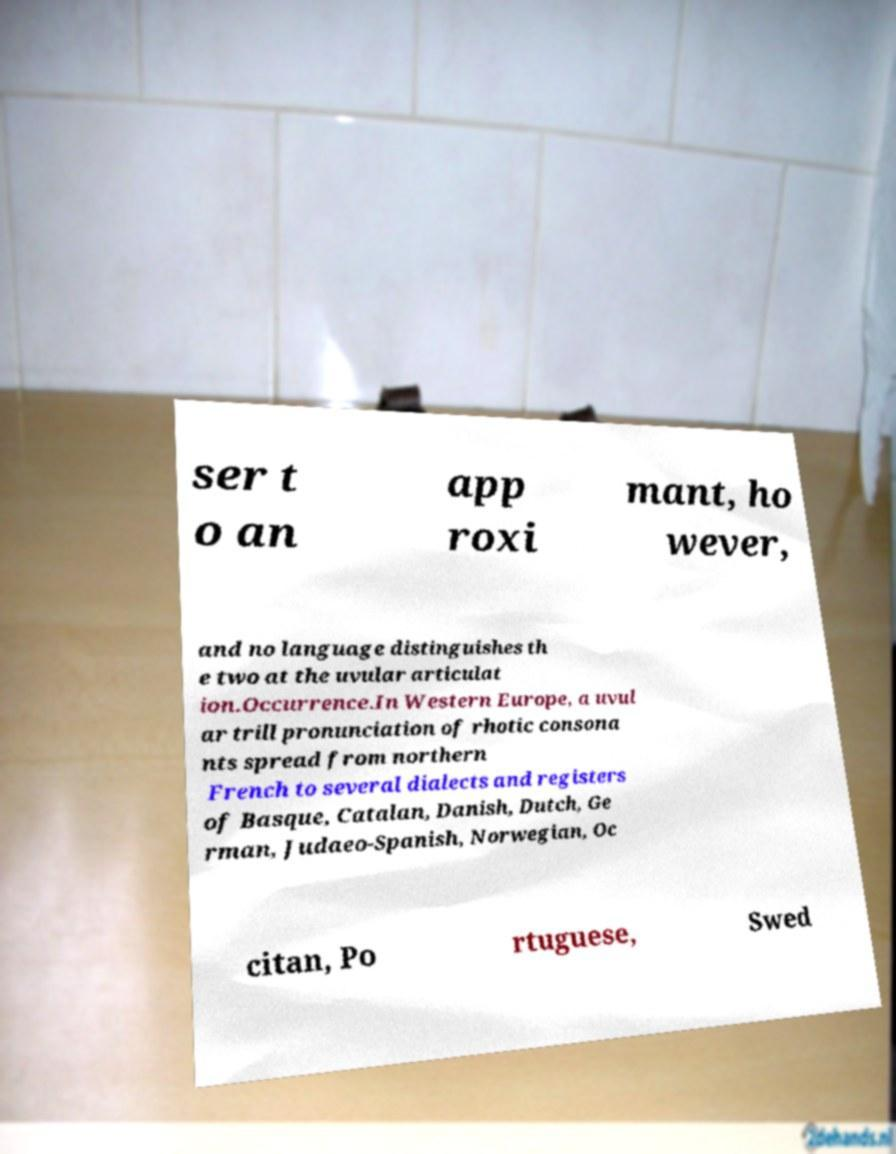Please identify and transcribe the text found in this image. ser t o an app roxi mant, ho wever, and no language distinguishes th e two at the uvular articulat ion.Occurrence.In Western Europe, a uvul ar trill pronunciation of rhotic consona nts spread from northern French to several dialects and registers of Basque, Catalan, Danish, Dutch, Ge rman, Judaeo-Spanish, Norwegian, Oc citan, Po rtuguese, Swed 